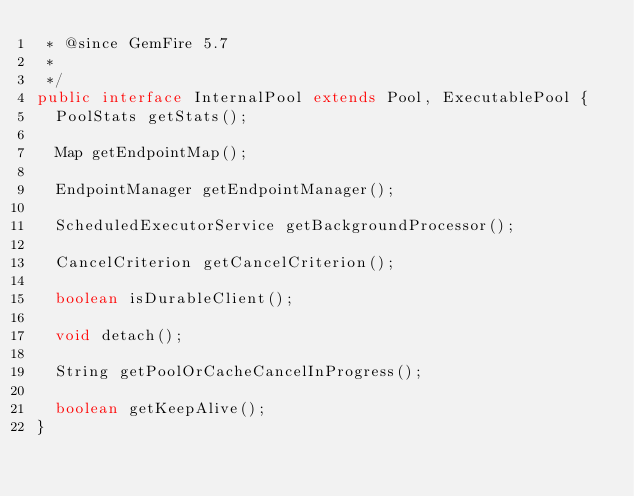Convert code to text. <code><loc_0><loc_0><loc_500><loc_500><_Java_> * @since GemFire 5.7
 *
 */
public interface InternalPool extends Pool, ExecutablePool {
  PoolStats getStats();

  Map getEndpointMap();

  EndpointManager getEndpointManager();

  ScheduledExecutorService getBackgroundProcessor();

  CancelCriterion getCancelCriterion();

  boolean isDurableClient();

  void detach();

  String getPoolOrCacheCancelInProgress();

  boolean getKeepAlive();
}
</code> 